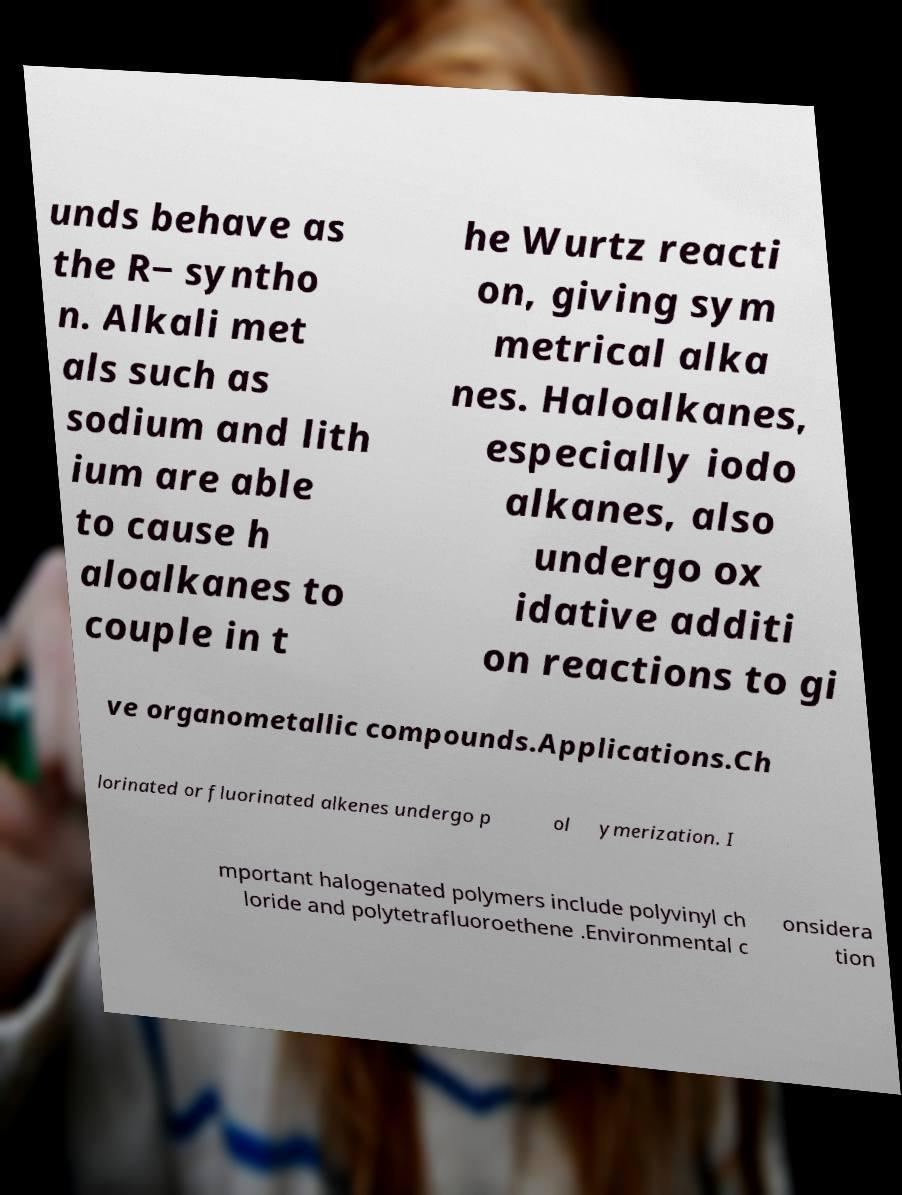Could you extract and type out the text from this image? unds behave as the R− syntho n. Alkali met als such as sodium and lith ium are able to cause h aloalkanes to couple in t he Wurtz reacti on, giving sym metrical alka nes. Haloalkanes, especially iodo alkanes, also undergo ox idative additi on reactions to gi ve organometallic compounds.Applications.Ch lorinated or fluorinated alkenes undergo p ol ymerization. I mportant halogenated polymers include polyvinyl ch loride and polytetrafluoroethene .Environmental c onsidera tion 